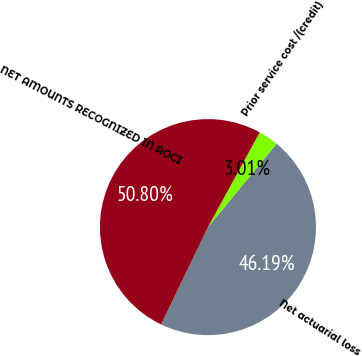Convert chart. <chart><loc_0><loc_0><loc_500><loc_500><pie_chart><fcel>Net actuarial loss<fcel>Prior service cost /(credit)<fcel>NET AMOUNTS RECOGNIZED IN AOCI<nl><fcel>46.19%<fcel>3.01%<fcel>50.81%<nl></chart> 